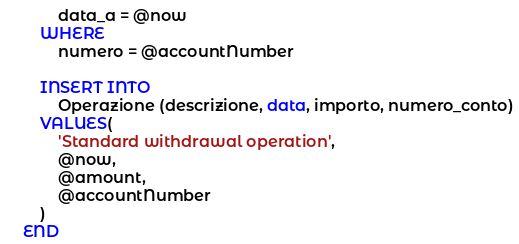<code> <loc_0><loc_0><loc_500><loc_500><_SQL_>			data_a = @now
		WHERE
			numero = @accountNumber

		INSERT INTO
			Operazione (descrizione, data, importo, numero_conto)
		VALUES(
			'Standard withdrawal operation',
			@now,
			@amount,
			@accountNumber
		)
	END</code> 